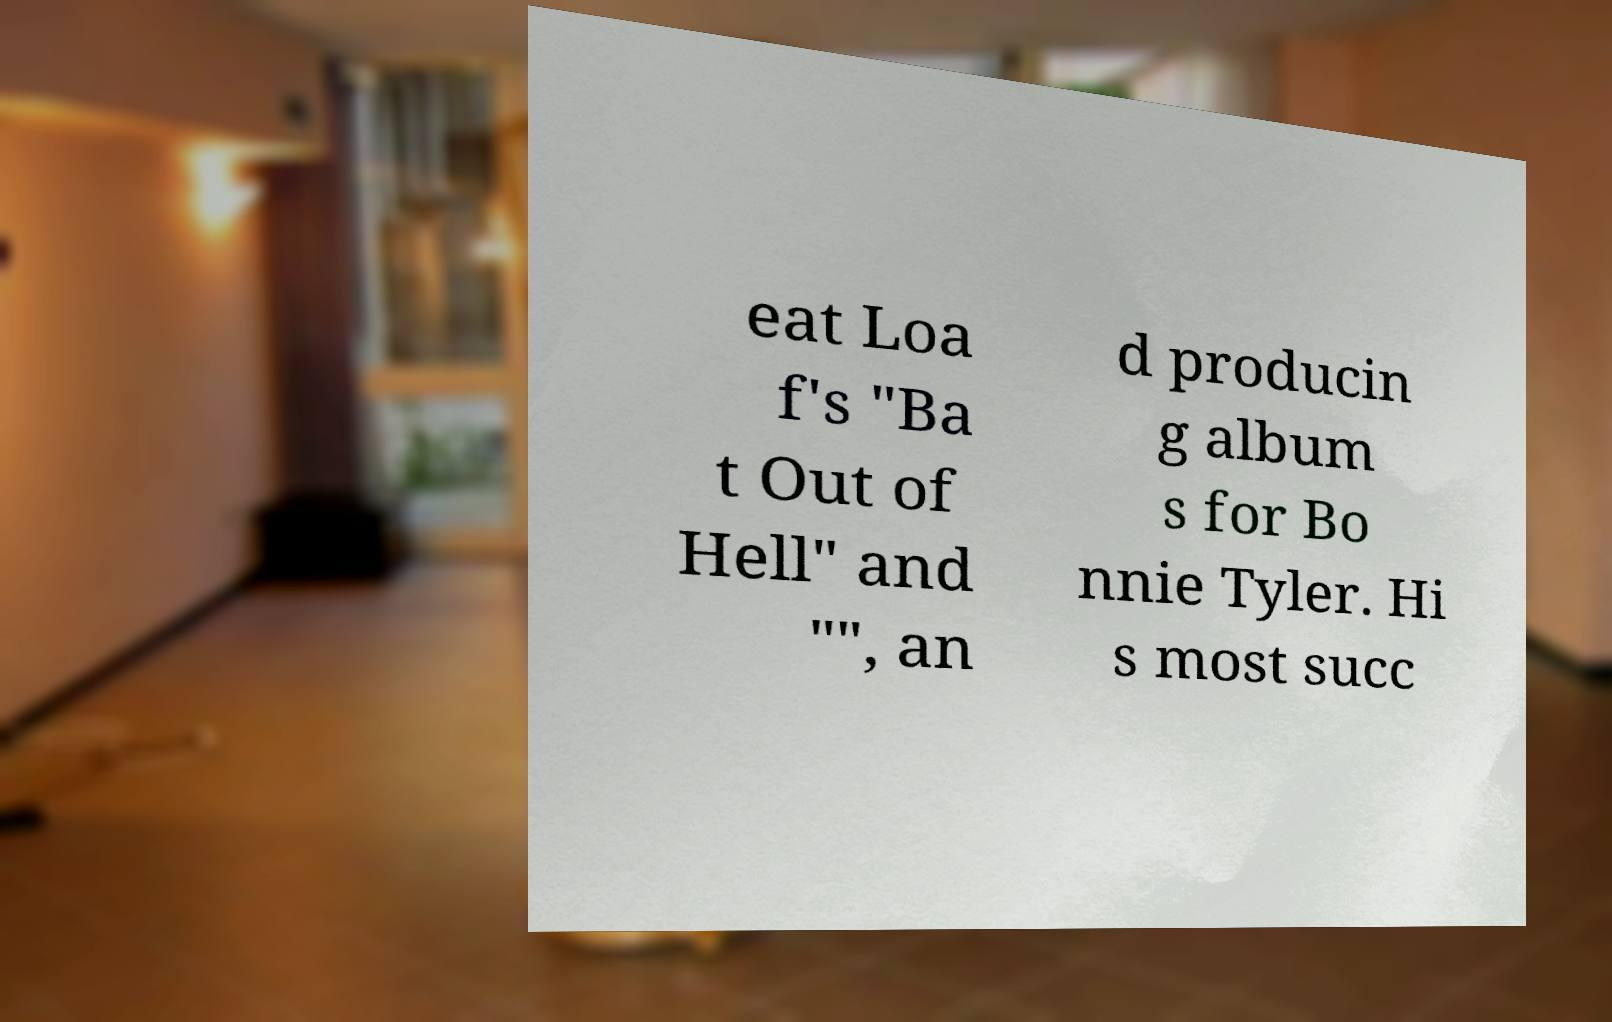I need the written content from this picture converted into text. Can you do that? eat Loa f's "Ba t Out of Hell" and "", an d producin g album s for Bo nnie Tyler. Hi s most succ 